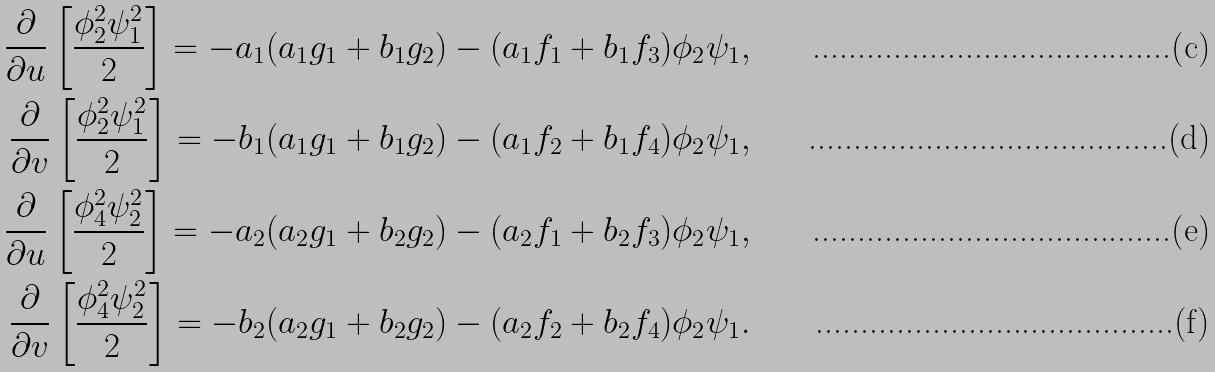Convert formula to latex. <formula><loc_0><loc_0><loc_500><loc_500>\frac { \partial } { \partial u } \left [ \frac { \phi _ { 2 } ^ { 2 } \psi _ { 1 } ^ { 2 } } { 2 } \right ] = - a _ { 1 } ( a _ { 1 } g _ { 1 } + b _ { 1 } g _ { 2 } ) - ( a _ { 1 } f _ { 1 } + b _ { 1 } f _ { 3 } ) \phi _ { 2 } \psi _ { 1 } , \\ \frac { \partial } { \partial v } \left [ \frac { \phi _ { 2 } ^ { 2 } \psi _ { 1 } ^ { 2 } } { 2 } \right ] = - b _ { 1 } ( a _ { 1 } g _ { 1 } + b _ { 1 } g _ { 2 } ) - ( a _ { 1 } f _ { 2 } + b _ { 1 } f _ { 4 } ) \phi _ { 2 } \psi _ { 1 } , \\ \frac { \partial } { \partial u } \left [ \frac { \phi _ { 4 } ^ { 2 } \psi _ { 2 } ^ { 2 } } { 2 } \right ] = - a _ { 2 } ( a _ { 2 } g _ { 1 } + b _ { 2 } g _ { 2 } ) - ( a _ { 2 } f _ { 1 } + b _ { 2 } f _ { 3 } ) \phi _ { 2 } \psi _ { 1 } , \\ \frac { \partial } { \partial v } \left [ \frac { \phi _ { 4 } ^ { 2 } \psi _ { 2 } ^ { 2 } } { 2 } \right ] = - b _ { 2 } ( a _ { 2 } g _ { 1 } + b _ { 2 } g _ { 2 } ) - ( a _ { 2 } f _ { 2 } + b _ { 2 } f _ { 4 } ) \phi _ { 2 } \psi _ { 1 } .</formula> 